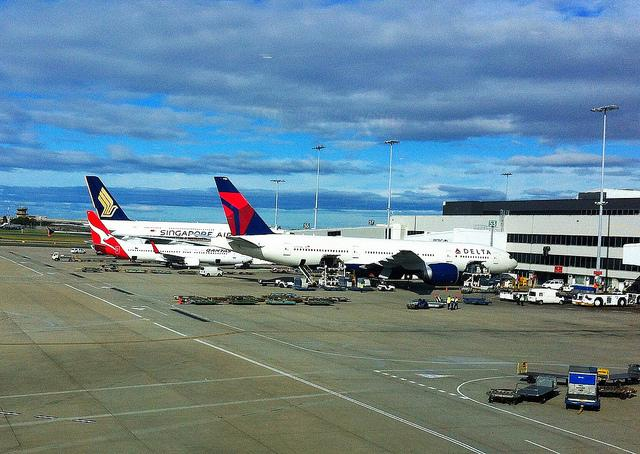How many different airlines are being featured by the planes in the photo?

Choices:
A) one
B) two
C) three
D) four three 